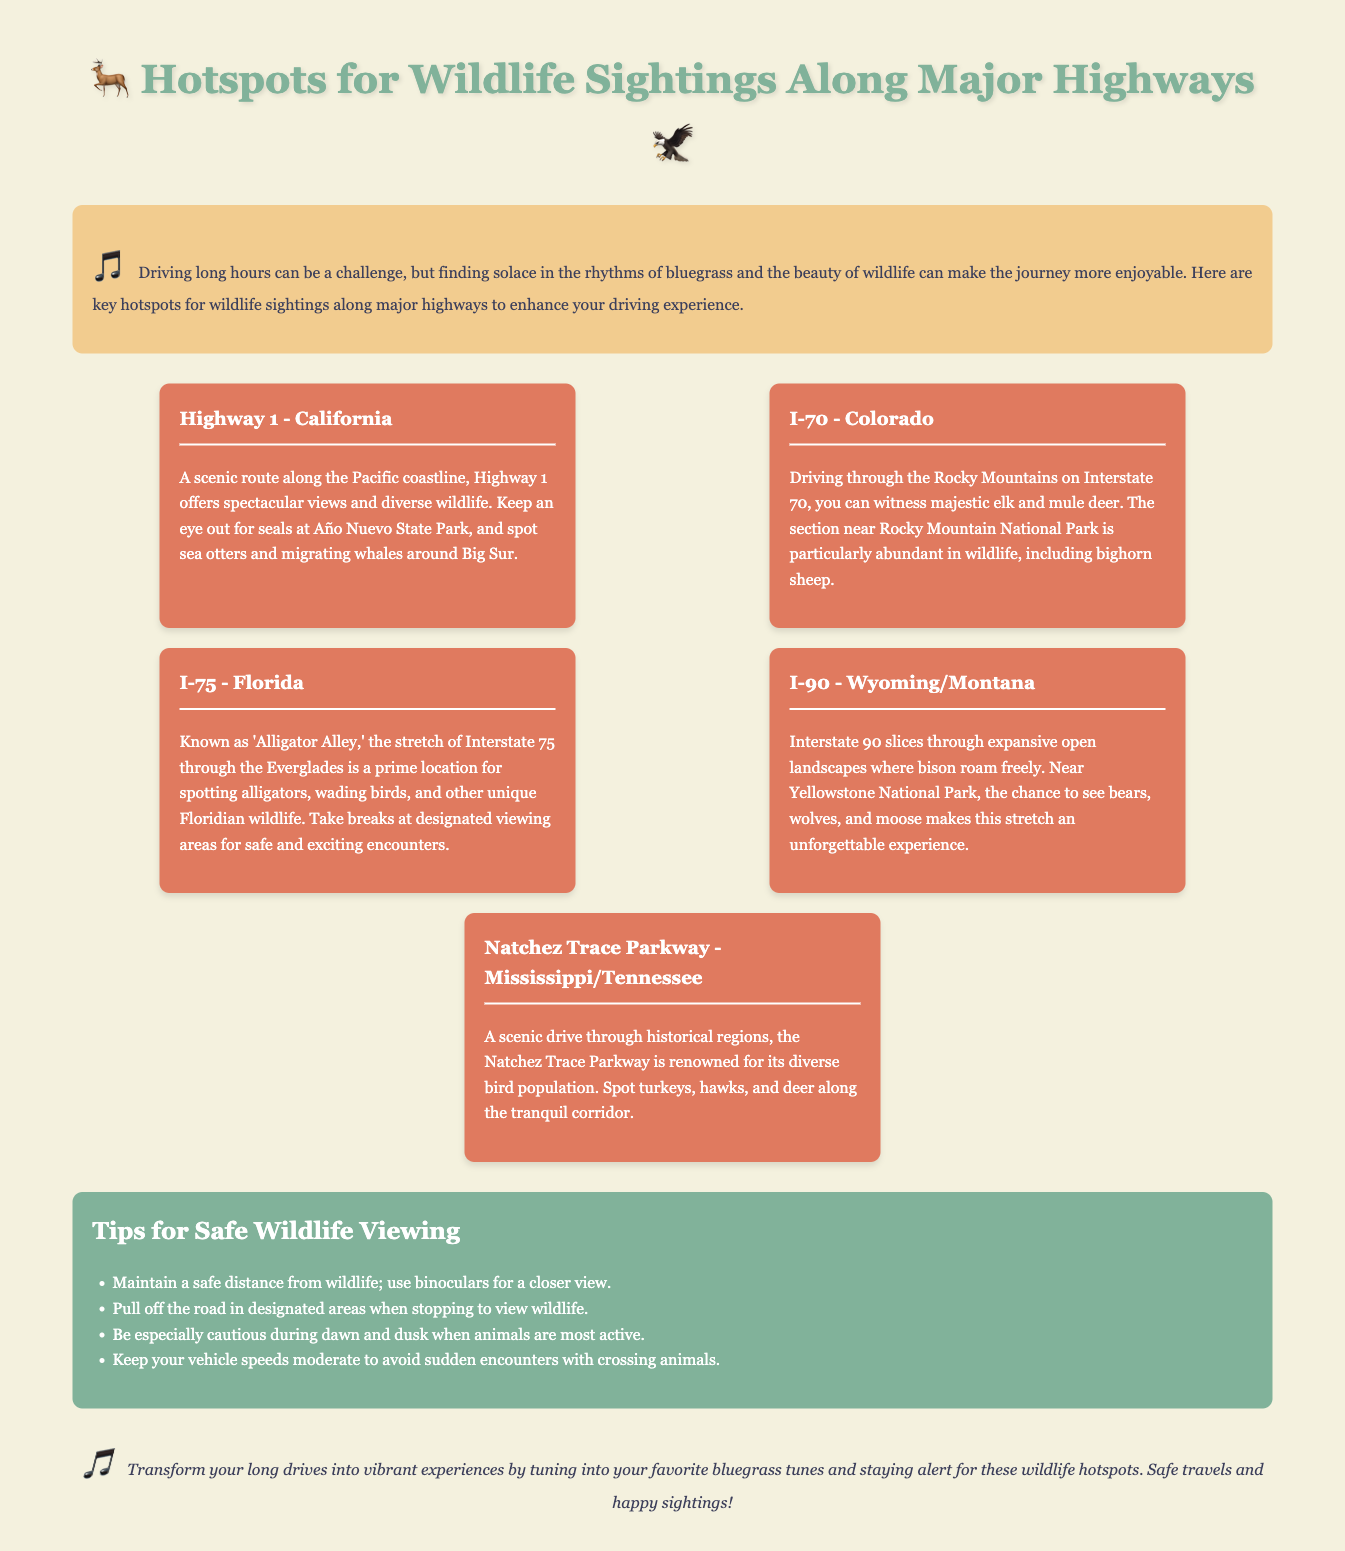What highway offers views of seals at Año Nuevo State Park? The document states that Highway 1 in California offers views of seals at Año Nuevo State Park.
Answer: Highway 1 Which wildlife can be spotted near Rocky Mountain National Park on I-70? The document mentions that majestic elk and mule deer, along with bighorn sheep, can be seen in this area.
Answer: Elk, mule deer, bighorn sheep What unique wildlife is the stretch of I-75 known for? The document refers to this stretch as 'Alligator Alley,' highlighting alligators as the unique wildlife there.
Answer: Alligators What tips are provided for safe wildlife viewing? The document lists tips such as maintaining a safe distance and pulling off the road in designated areas.
Answer: Maintain a safe distance How does the Natchez Trace Parkway support bird watching? The document states it is renowned for its diverse bird population, where birds such as turkeys and hawks can be spotted.
Answer: Diverse bird population 